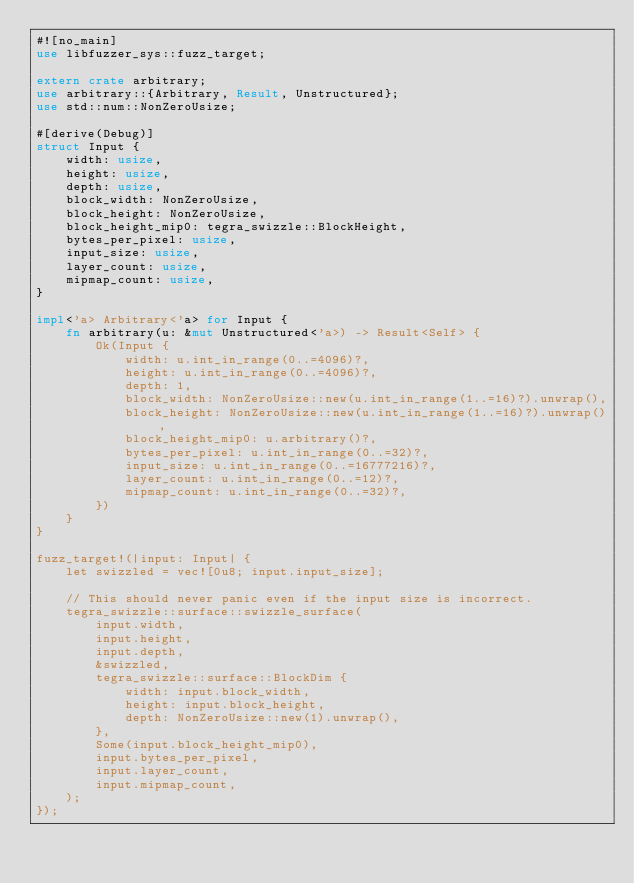Convert code to text. <code><loc_0><loc_0><loc_500><loc_500><_Rust_>#![no_main]
use libfuzzer_sys::fuzz_target;

extern crate arbitrary;
use arbitrary::{Arbitrary, Result, Unstructured};
use std::num::NonZeroUsize;

#[derive(Debug)]
struct Input {
    width: usize,
    height: usize,
    depth: usize,
    block_width: NonZeroUsize,
    block_height: NonZeroUsize,
    block_height_mip0: tegra_swizzle::BlockHeight,
    bytes_per_pixel: usize,
    input_size: usize,
    layer_count: usize,
    mipmap_count: usize,
}

impl<'a> Arbitrary<'a> for Input {
    fn arbitrary(u: &mut Unstructured<'a>) -> Result<Self> {
        Ok(Input {
            width: u.int_in_range(0..=4096)?,
            height: u.int_in_range(0..=4096)?,
            depth: 1,
            block_width: NonZeroUsize::new(u.int_in_range(1..=16)?).unwrap(),
            block_height: NonZeroUsize::new(u.int_in_range(1..=16)?).unwrap(),
            block_height_mip0: u.arbitrary()?,
            bytes_per_pixel: u.int_in_range(0..=32)?,
            input_size: u.int_in_range(0..=16777216)?,
            layer_count: u.int_in_range(0..=12)?,
            mipmap_count: u.int_in_range(0..=32)?,
        })
    }
}

fuzz_target!(|input: Input| {
    let swizzled = vec![0u8; input.input_size];

    // This should never panic even if the input size is incorrect.
    tegra_swizzle::surface::swizzle_surface(
        input.width,
        input.height,
        input.depth,
        &swizzled,
        tegra_swizzle::surface::BlockDim {
            width: input.block_width,
            height: input.block_height,
            depth: NonZeroUsize::new(1).unwrap(),
        },
        Some(input.block_height_mip0),
        input.bytes_per_pixel,
        input.layer_count,
        input.mipmap_count,
    );
});
</code> 